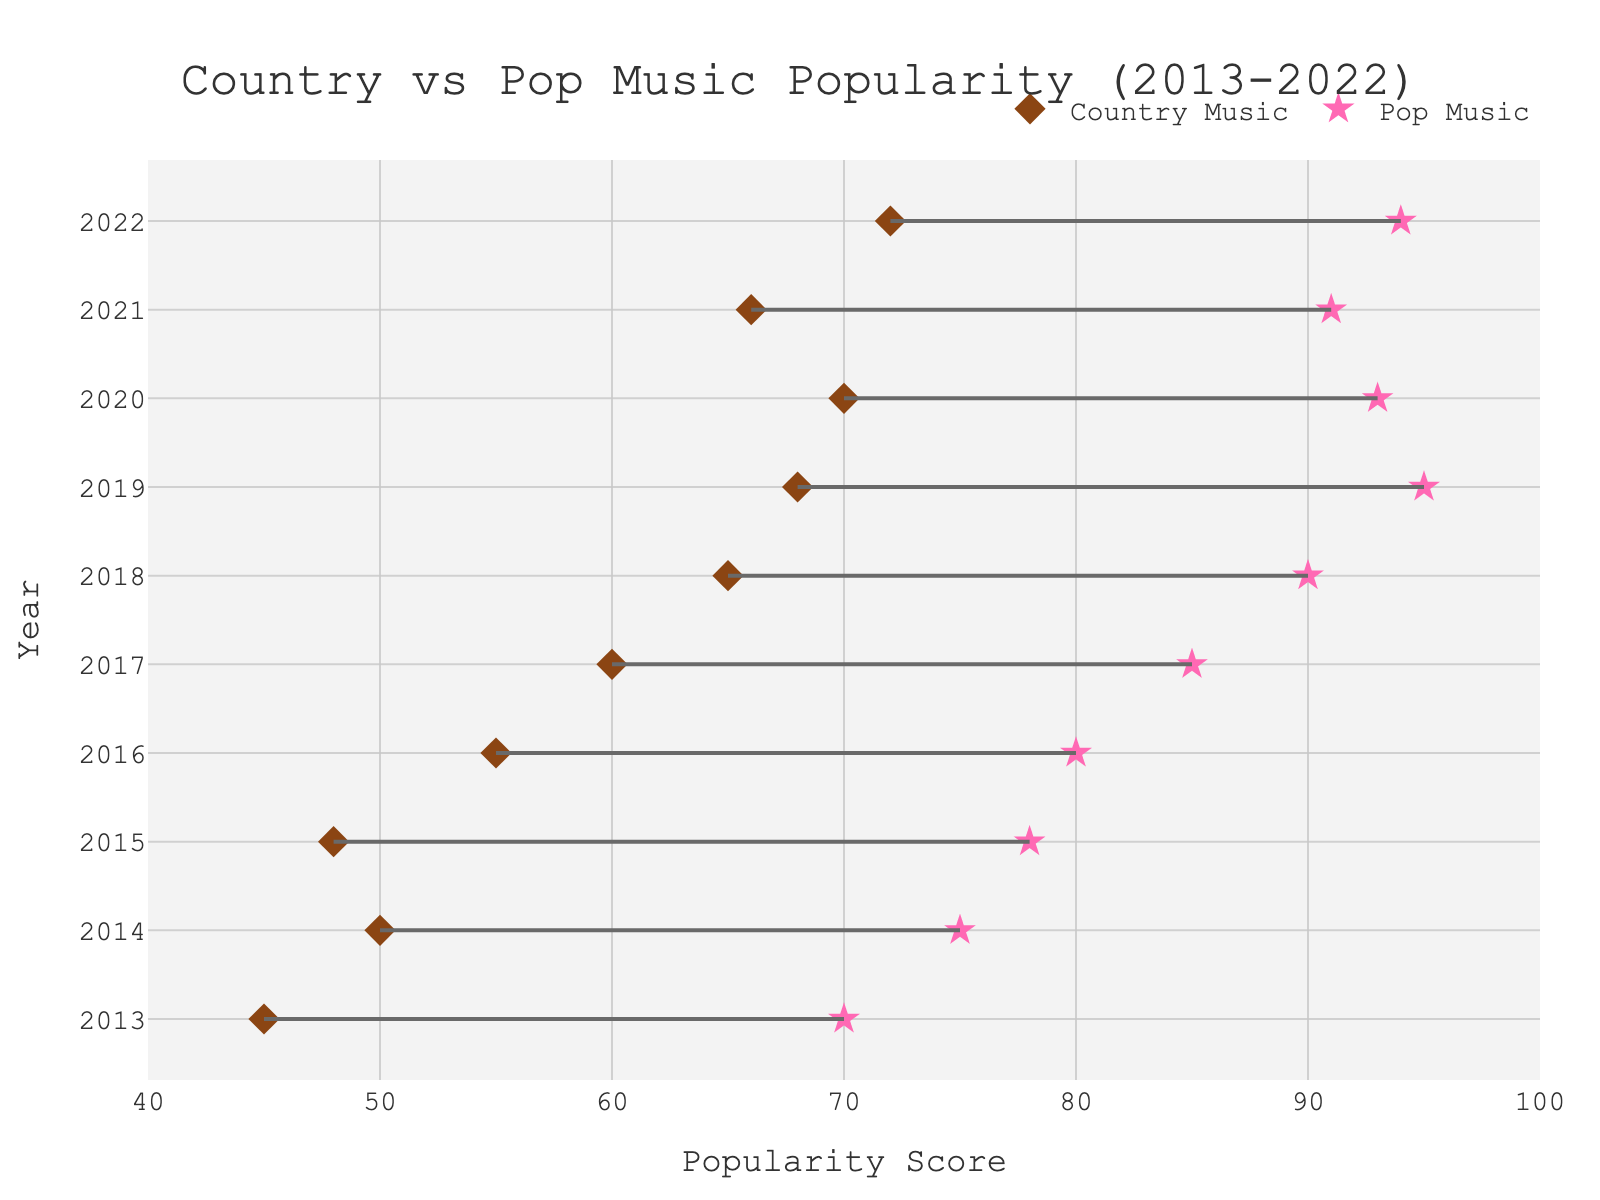What's the title of the plot? The title is typically located at the top of the plot and serves to give a brief summary of what the data represents. In this case, it reads "Country vs Pop Music Popularity (2013-2022)."
Answer: Country vs Pop Music Popularity (2013-2022) How many years does the plot cover? The y-axis ranges from 2013 to 2022, indicating that it covers a span of 10 years.
Answer: 10 Which genre had the highest popularity score in 2018? To find this, we look at the markers for the year 2018 and compare the scores for Country Music and Pop Music. Pop Music has a score of 90, while Country Music has 65.
Answer: Pop Music What is the difference in popularity scores for Country Music and Pop Music in 2015? We subtract the popularity score of Country Music from that of Pop Music for the year 2015. For 2015, Pop Music has a score of 78 and Country Music has 48. Therefore, 78 - 48 = 30.
Answer: 30 Has the popularity of Country Music increased or decreased over the decade? By looking at the markers for Country Music from 2013 to 2022, we see a general increasing trend from 45 in 2013 to 72 in 2022.
Answer: Increased What is the average popularity score of Pop Music over the decade? To compute the average, sum all the yearly popularity scores of Pop Music from 2013 to 2022 and divide by the number of years. (70 + 75 + 78 + 80 + 85 + 90 + 95 + 93 + 91 + 94) / 10 = 85.1.
Answer: 85.1 In which year did Country Music experience its largest single-year increase in popularity? To determine the largest increase, we calculate the yearly differences for Country Music and compare them. The largest increase happens between 2017 and 2018, rising from 60 to 65, so an increase of 5.
Answer: 2018 How does the popularity of Pop Music in 2022 compare to that of Country Music in the same year? By observing the markers for 2022, Pop Music has a score of 94 and Country Music has a score of 72. Pop Music is more popular in 2022.
Answer: Pop Music is more popular Which genre showed more stability in its popularity scores over the decade? To determine stability, observe the fluctuation in the data points for each genre. Pop Music shows fewer fluctuations, consistently remaining high, whereas Country Music has more variation.
Answer: Pop Music 